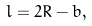Convert formula to latex. <formula><loc_0><loc_0><loc_500><loc_500>l = 2 R - b ,</formula> 